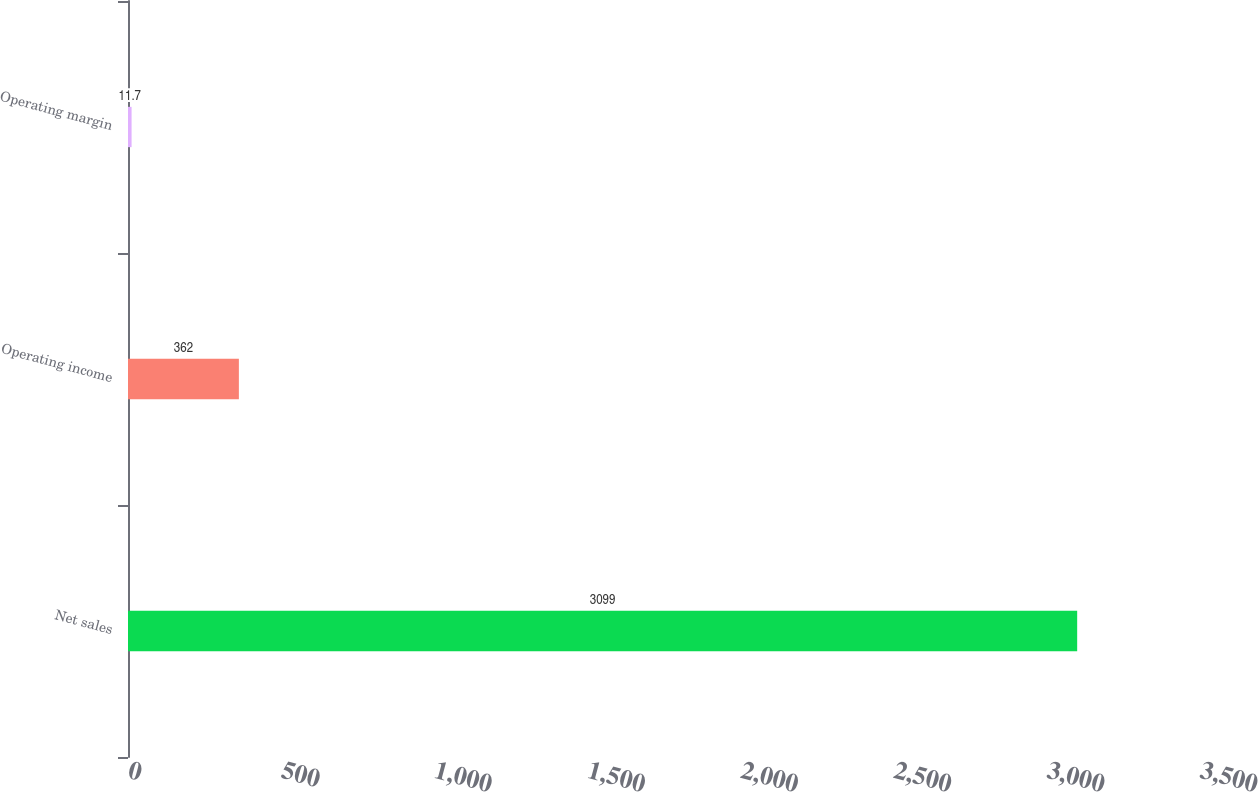Convert chart. <chart><loc_0><loc_0><loc_500><loc_500><bar_chart><fcel>Net sales<fcel>Operating income<fcel>Operating margin<nl><fcel>3099<fcel>362<fcel>11.7<nl></chart> 